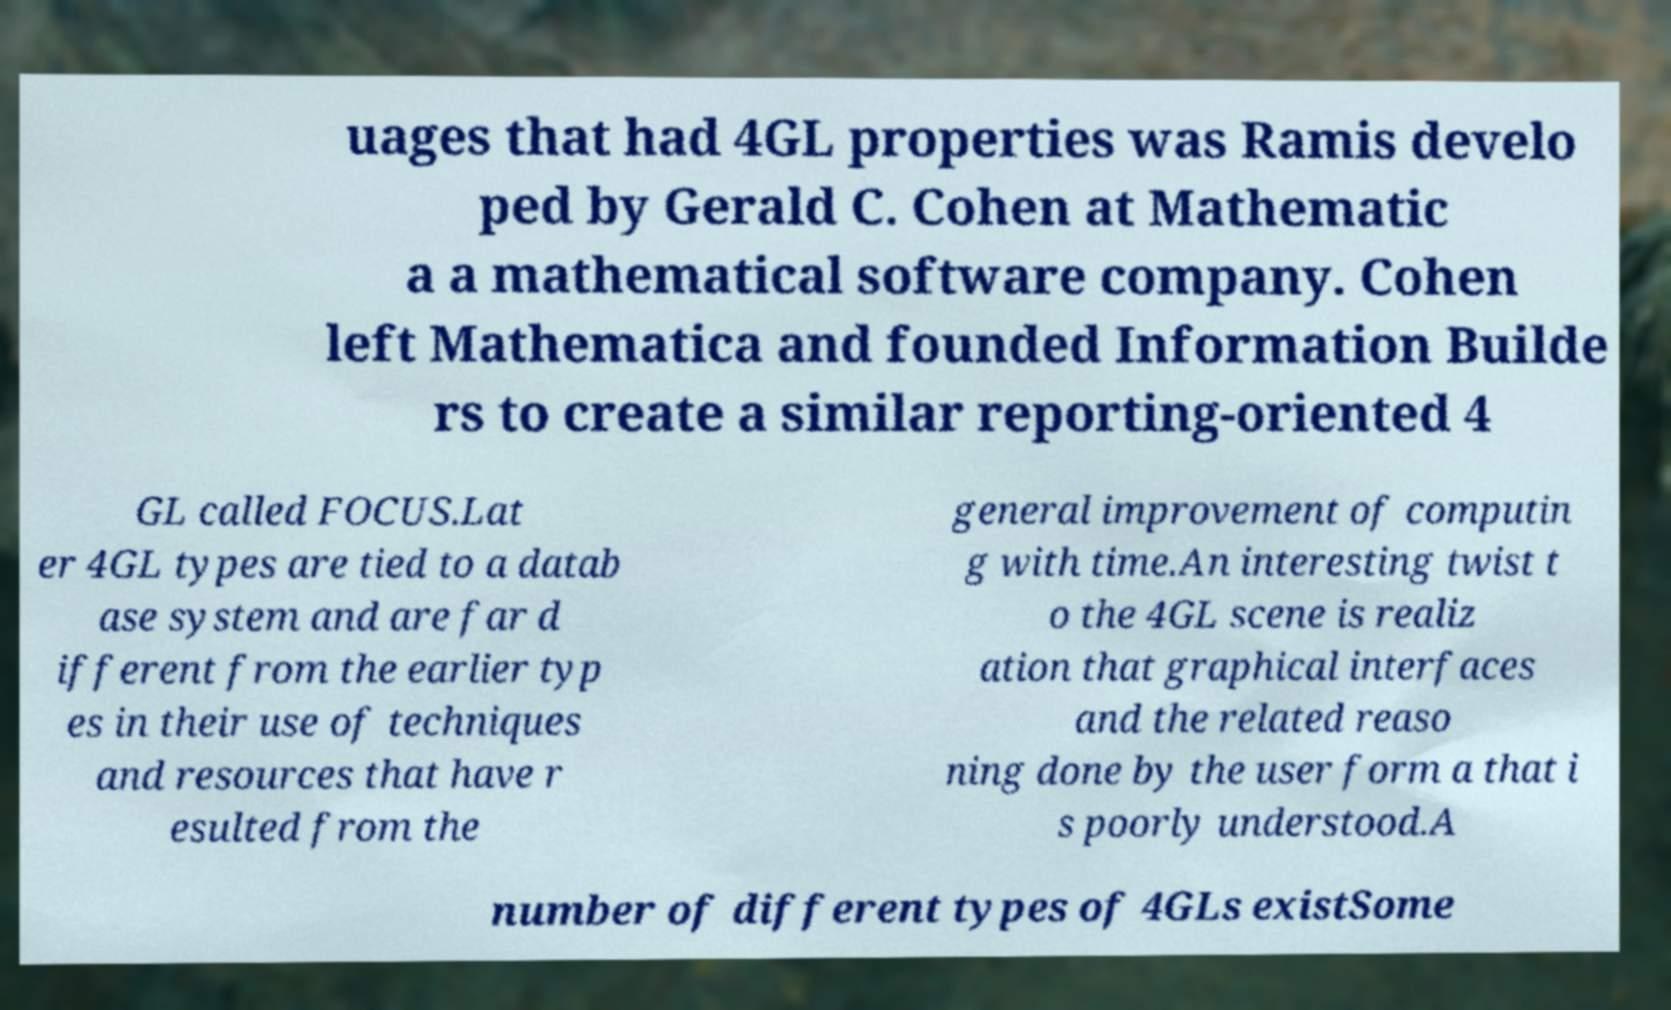Can you accurately transcribe the text from the provided image for me? uages that had 4GL properties was Ramis develo ped by Gerald C. Cohen at Mathematic a a mathematical software company. Cohen left Mathematica and founded Information Builde rs to create a similar reporting-oriented 4 GL called FOCUS.Lat er 4GL types are tied to a datab ase system and are far d ifferent from the earlier typ es in their use of techniques and resources that have r esulted from the general improvement of computin g with time.An interesting twist t o the 4GL scene is realiz ation that graphical interfaces and the related reaso ning done by the user form a that i s poorly understood.A number of different types of 4GLs existSome 